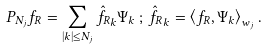<formula> <loc_0><loc_0><loc_500><loc_500>P _ { N _ { j } } f _ { R } = \sum _ { | k | \leq N _ { j } } \hat { f _ { R } } _ { k } \Psi _ { k } \, ; \, \hat { f _ { R } } _ { k } = \left < f _ { R } , \Psi _ { k } \right > _ { w _ { j } } .</formula> 